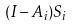Convert formula to latex. <formula><loc_0><loc_0><loc_500><loc_500>( I - A _ { i } ) S _ { i }</formula> 